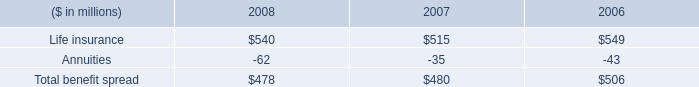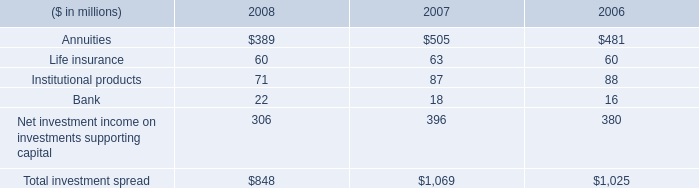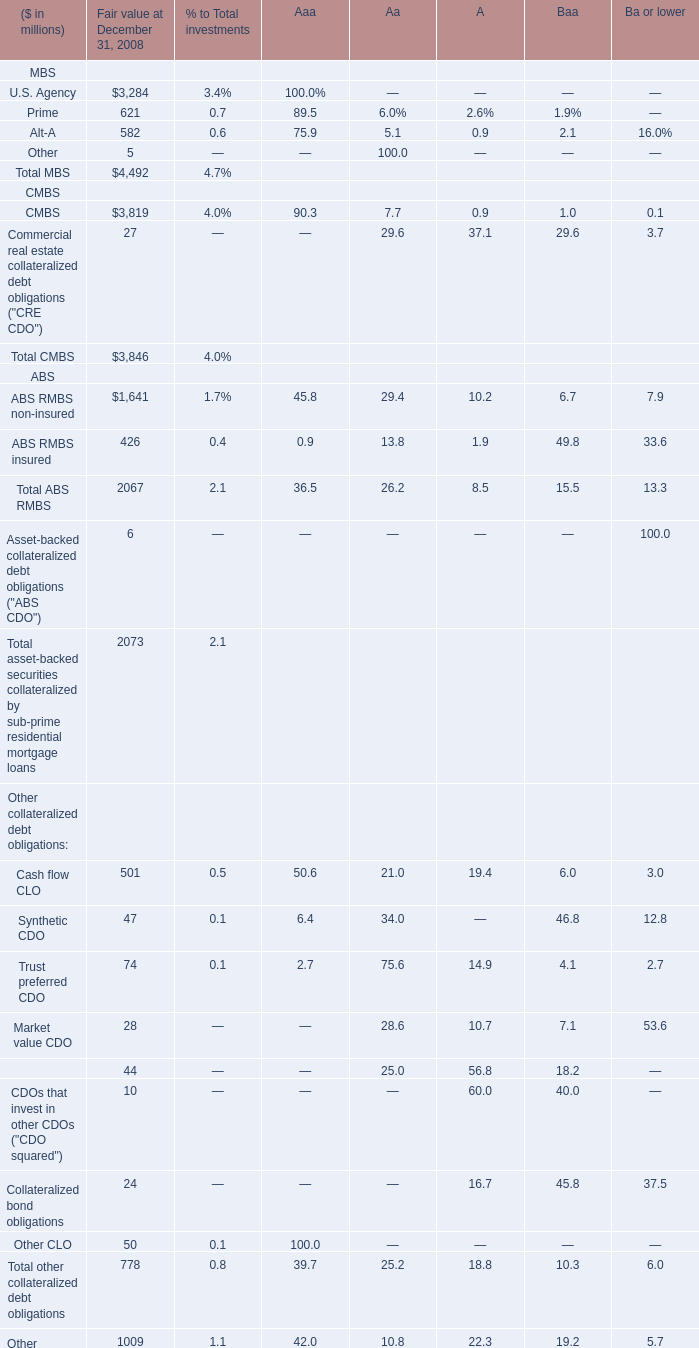What's the total amount of MBS in 2008? (in million) 
Computations: (((3284 + 621) + 582) + 5)
Answer: 4492.0. 